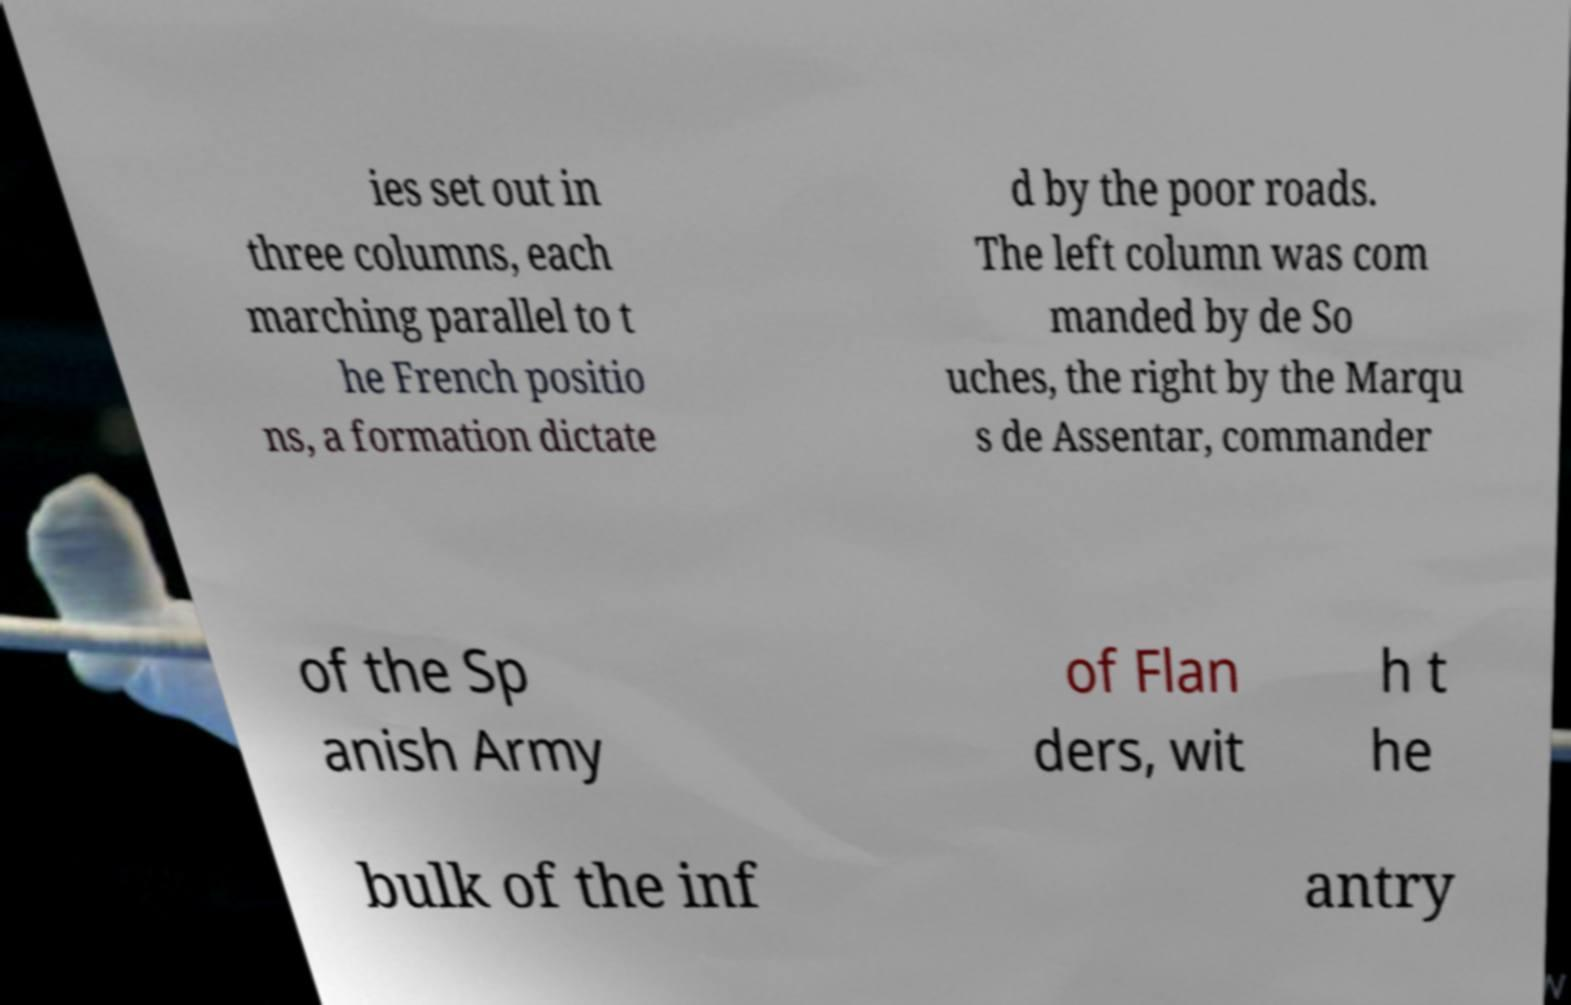Can you read and provide the text displayed in the image?This photo seems to have some interesting text. Can you extract and type it out for me? ies set out in three columns, each marching parallel to t he French positio ns, a formation dictate d by the poor roads. The left column was com manded by de So uches, the right by the Marqu s de Assentar, commander of the Sp anish Army of Flan ders, wit h t he bulk of the inf antry 